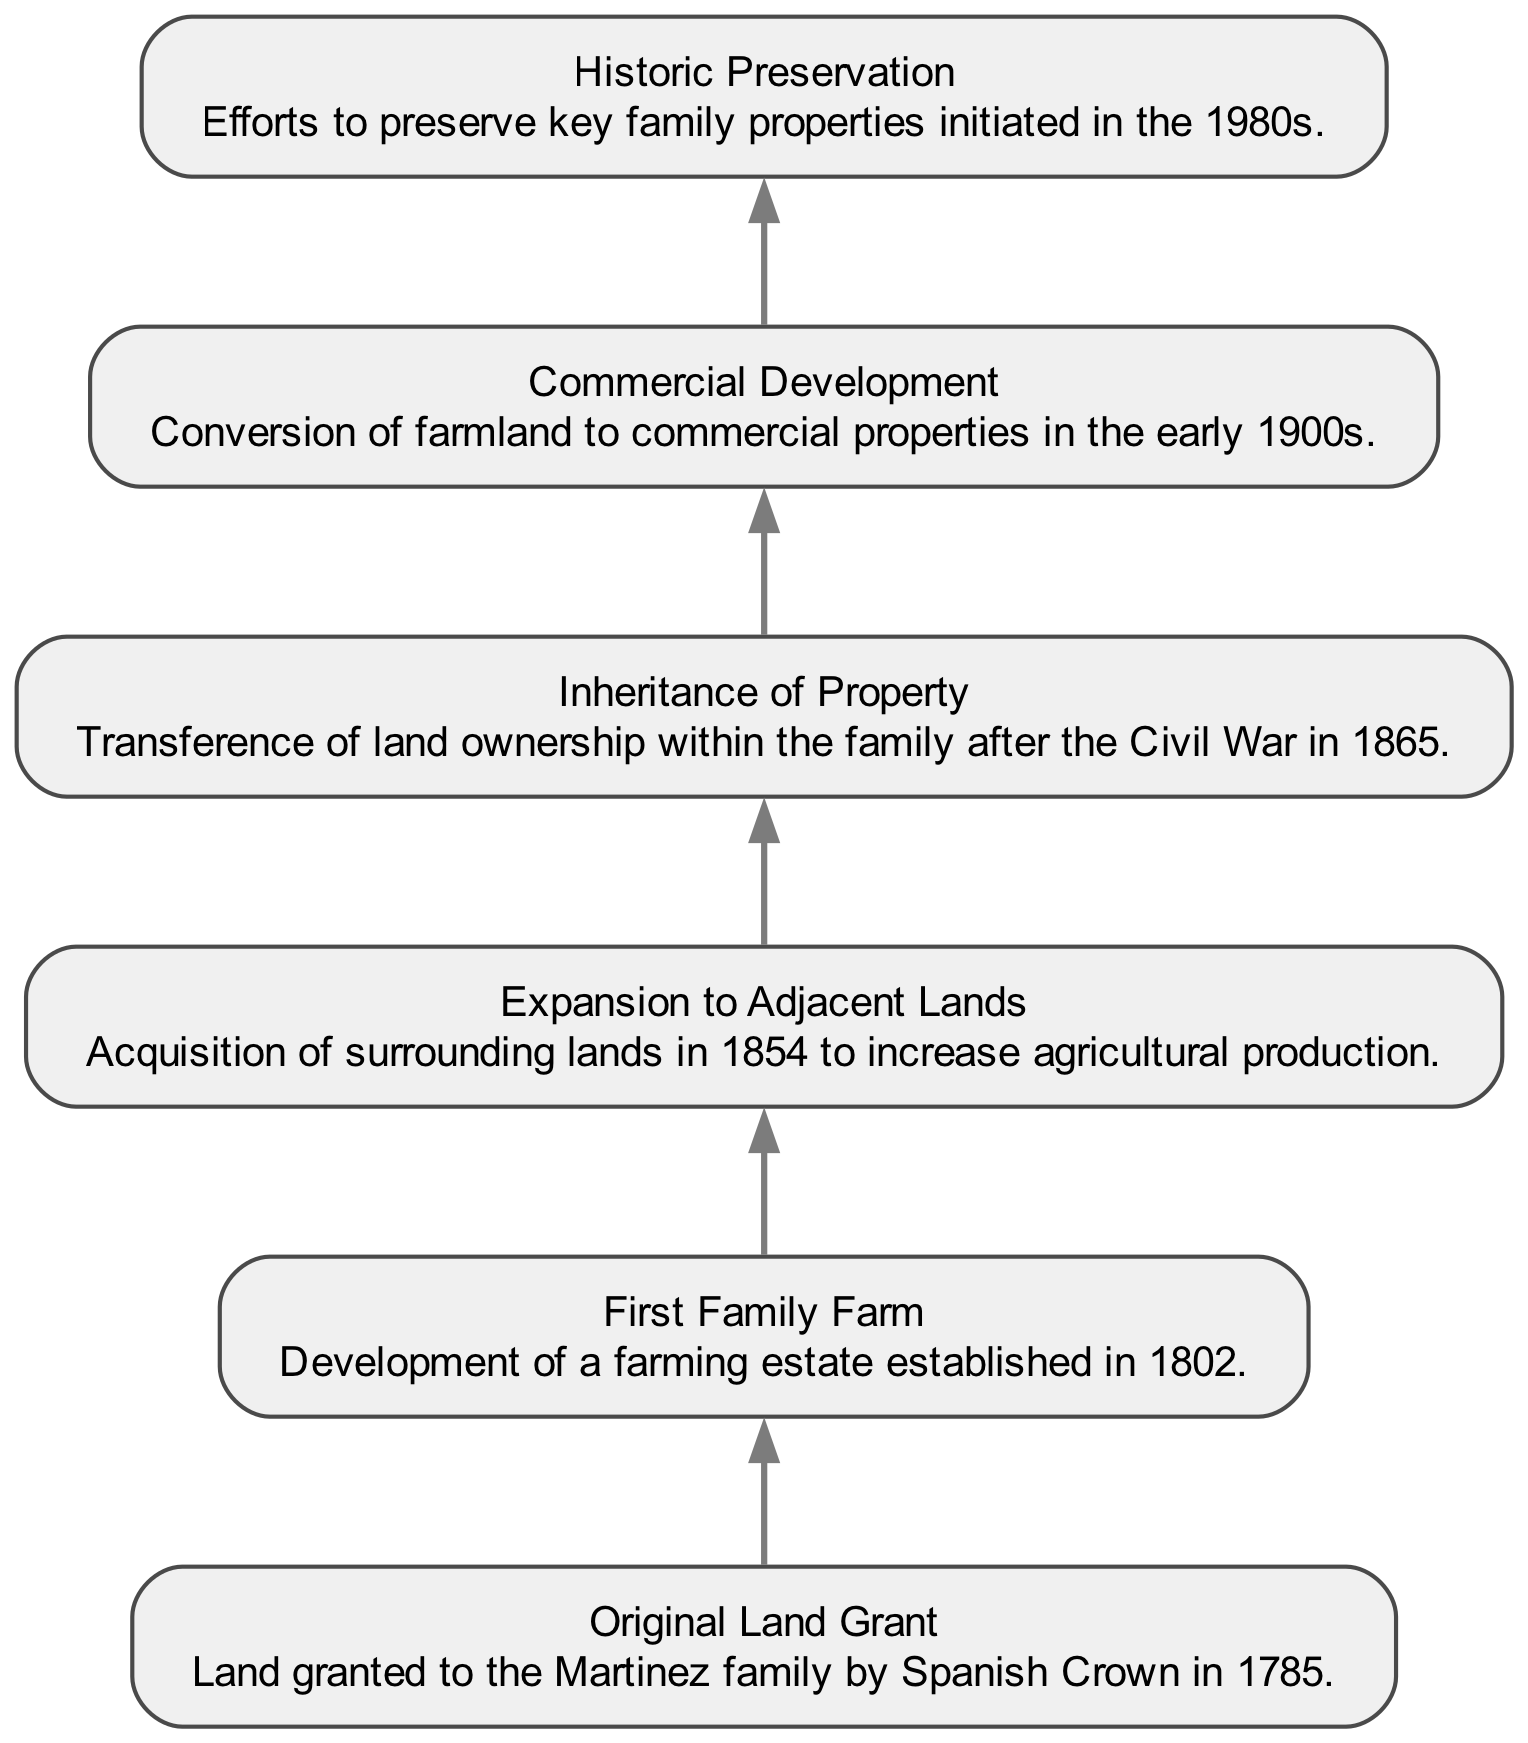What is the original year of the land grant? The diagram indicates that the "Original Land Grant" was granted in 1785.
Answer: 1785 What significant development occurred in 1802? According to the diagram, the "First Family Farm" was established in 1802, marking the beginning of farming activities by the Martinez family.
Answer: First Family Farm How many significant property ownership milestones are illustrated in the diagram? By examining the diagram, there are a total of six distinct elements related to land ownership milestones in the Martinez family history.
Answer: 6 What event corresponds to the year 1865 in the Martinez family history? The diagram shows "Inheritance of Property" as the key event in 1865, which represents the transference of land ownership within the family post-Civil War.
Answer: Inheritance of Property What transformation of land use happened in the early 1900s? The diagram indicates that "Commercial Development" took place in the early 1900s, where farmland was converted into commercial properties.
Answer: Commercial Development Which event signifies the beginning of preservation efforts for the family properties? The diagram states that "Historic Preservation" efforts started in the 1980s, showing a significant shift towards maintenance and conservation of historic properties.
Answer: Historic Preservation Which property acquisition milestone directly follows the establishment of the family farm? According to the diagram, "Expansion to Adjacent Lands" follows the "First Family Farm," indicating acquisition efforts made to enhance agricultural production after the farm's establishment.
Answer: Expansion to Adjacent Lands How are the nodes connected in the diagram? The nodes are connected in a bottom-up manner, with each subsequent milestone building upon the previous one, indicating a historical progression of land ownership and development.
Answer: Bottom-up connection What is the primary focus of the timeline represented in the diagram? The timeline represents the history of "Historical Property Ownership" in the Martinez family, illustrating land acquisitions and developments over several centuries.
Answer: Historical Property Ownership 